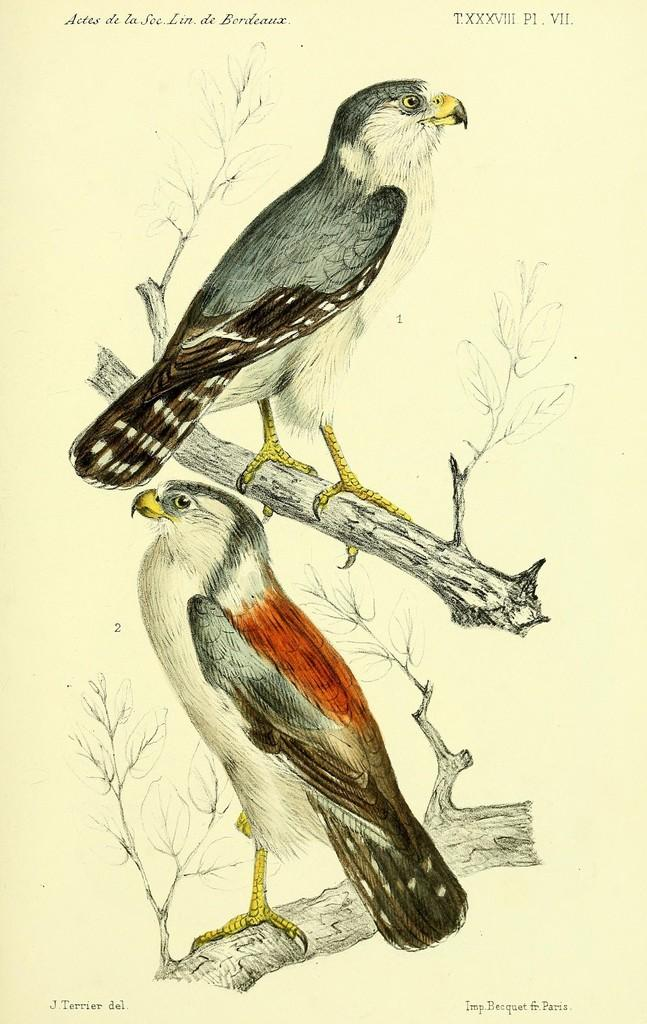What is the main subject of the art piece in the image? The art piece contains an image of two birds. Where are the birds located in the art piece? The birds are on the branches of a tree. What color is the background of the art piece? The background of the art piece is white. What material is the art piece created on? The birds are drawn on paper. How does the art piece expand when exposed to water? The art piece does not expand when exposed to water, as it is a static image drawn on paper. What type of glove is depicted in the art piece? There is no glove depicted in the art piece; it features two birds on the branches of a tree. 